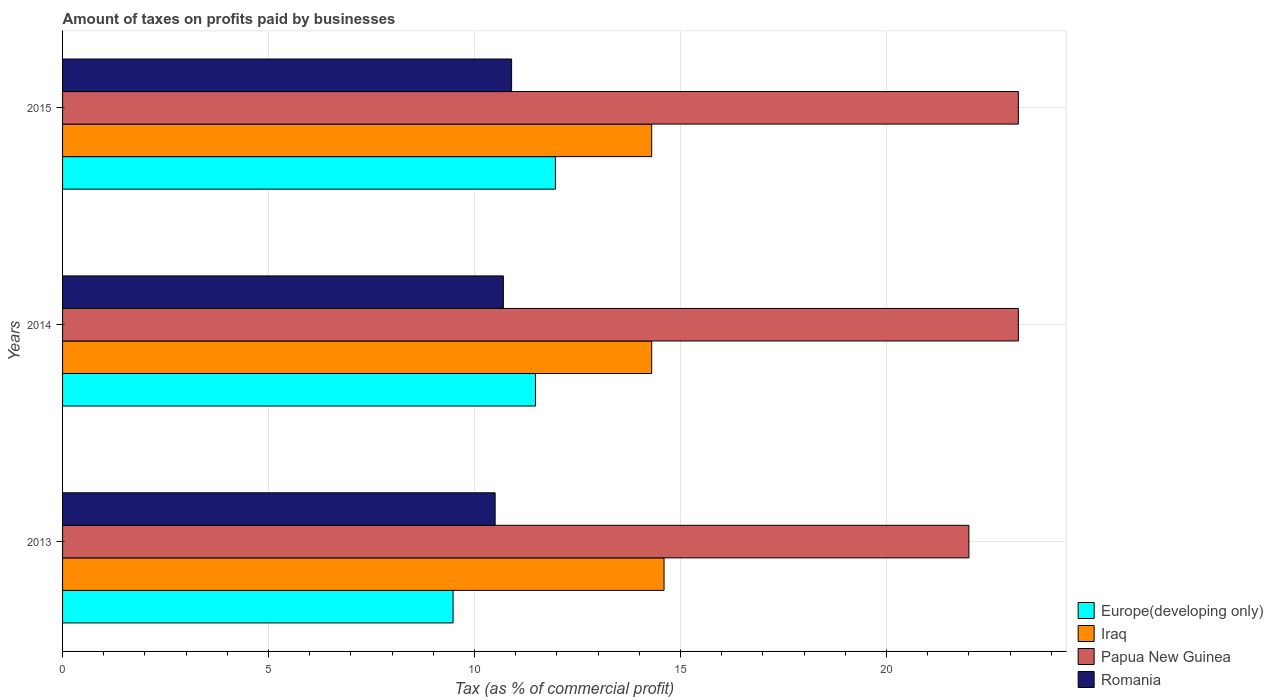How many different coloured bars are there?
Provide a short and direct response. 4. How many bars are there on the 3rd tick from the top?
Keep it short and to the point. 4. How many bars are there on the 2nd tick from the bottom?
Your answer should be compact. 4. What is the label of the 3rd group of bars from the top?
Your answer should be compact. 2013. In how many cases, is the number of bars for a given year not equal to the number of legend labels?
Offer a terse response. 0. Across all years, what is the maximum percentage of taxes paid by businesses in Papua New Guinea?
Offer a terse response. 23.2. In which year was the percentage of taxes paid by businesses in Romania maximum?
Offer a terse response. 2015. In which year was the percentage of taxes paid by businesses in Europe(developing only) minimum?
Give a very brief answer. 2013. What is the total percentage of taxes paid by businesses in Papua New Guinea in the graph?
Make the answer very short. 68.4. What is the difference between the percentage of taxes paid by businesses in Iraq in 2013 and that in 2014?
Offer a very short reply. 0.3. What is the difference between the percentage of taxes paid by businesses in Europe(developing only) in 2013 and the percentage of taxes paid by businesses in Iraq in 2015?
Provide a short and direct response. -4.82. In the year 2014, what is the difference between the percentage of taxes paid by businesses in Romania and percentage of taxes paid by businesses in Europe(developing only)?
Offer a very short reply. -0.78. In how many years, is the percentage of taxes paid by businesses in Papua New Guinea greater than 23 %?
Provide a succinct answer. 2. What is the ratio of the percentage of taxes paid by businesses in Europe(developing only) in 2013 to that in 2014?
Provide a short and direct response. 0.83. What is the difference between the highest and the second highest percentage of taxes paid by businesses in Romania?
Your answer should be very brief. 0.2. What is the difference between the highest and the lowest percentage of taxes paid by businesses in Europe(developing only)?
Provide a short and direct response. 2.48. In how many years, is the percentage of taxes paid by businesses in Romania greater than the average percentage of taxes paid by businesses in Romania taken over all years?
Offer a terse response. 1. Is it the case that in every year, the sum of the percentage of taxes paid by businesses in Papua New Guinea and percentage of taxes paid by businesses in Romania is greater than the sum of percentage of taxes paid by businesses in Iraq and percentage of taxes paid by businesses in Europe(developing only)?
Ensure brevity in your answer.  Yes. What does the 4th bar from the top in 2013 represents?
Give a very brief answer. Europe(developing only). What does the 1st bar from the bottom in 2014 represents?
Offer a terse response. Europe(developing only). Are all the bars in the graph horizontal?
Provide a short and direct response. Yes. How many years are there in the graph?
Keep it short and to the point. 3. Does the graph contain grids?
Make the answer very short. Yes. How many legend labels are there?
Offer a very short reply. 4. What is the title of the graph?
Ensure brevity in your answer.  Amount of taxes on profits paid by businesses. What is the label or title of the X-axis?
Provide a short and direct response. Tax (as % of commercial profit). What is the Tax (as % of commercial profit) of Europe(developing only) in 2013?
Give a very brief answer. 9.48. What is the Tax (as % of commercial profit) of Romania in 2013?
Provide a short and direct response. 10.5. What is the Tax (as % of commercial profit) of Europe(developing only) in 2014?
Make the answer very short. 11.48. What is the Tax (as % of commercial profit) of Iraq in 2014?
Give a very brief answer. 14.3. What is the Tax (as % of commercial profit) in Papua New Guinea in 2014?
Offer a very short reply. 23.2. What is the Tax (as % of commercial profit) of Europe(developing only) in 2015?
Provide a succinct answer. 11.96. What is the Tax (as % of commercial profit) in Papua New Guinea in 2015?
Offer a terse response. 23.2. What is the Tax (as % of commercial profit) of Romania in 2015?
Provide a succinct answer. 10.9. Across all years, what is the maximum Tax (as % of commercial profit) in Europe(developing only)?
Provide a short and direct response. 11.96. Across all years, what is the maximum Tax (as % of commercial profit) of Papua New Guinea?
Provide a short and direct response. 23.2. Across all years, what is the minimum Tax (as % of commercial profit) of Europe(developing only)?
Offer a terse response. 9.48. Across all years, what is the minimum Tax (as % of commercial profit) in Romania?
Your response must be concise. 10.5. What is the total Tax (as % of commercial profit) of Europe(developing only) in the graph?
Offer a very short reply. 32.92. What is the total Tax (as % of commercial profit) of Iraq in the graph?
Keep it short and to the point. 43.2. What is the total Tax (as % of commercial profit) of Papua New Guinea in the graph?
Your answer should be compact. 68.4. What is the total Tax (as % of commercial profit) in Romania in the graph?
Keep it short and to the point. 32.1. What is the difference between the Tax (as % of commercial profit) in Europe(developing only) in 2013 and that in 2014?
Give a very brief answer. -2. What is the difference between the Tax (as % of commercial profit) in Iraq in 2013 and that in 2014?
Ensure brevity in your answer.  0.3. What is the difference between the Tax (as % of commercial profit) in Papua New Guinea in 2013 and that in 2014?
Ensure brevity in your answer.  -1.2. What is the difference between the Tax (as % of commercial profit) in Romania in 2013 and that in 2014?
Provide a short and direct response. -0.2. What is the difference between the Tax (as % of commercial profit) in Europe(developing only) in 2013 and that in 2015?
Ensure brevity in your answer.  -2.48. What is the difference between the Tax (as % of commercial profit) in Iraq in 2013 and that in 2015?
Give a very brief answer. 0.3. What is the difference between the Tax (as % of commercial profit) in Papua New Guinea in 2013 and that in 2015?
Offer a terse response. -1.2. What is the difference between the Tax (as % of commercial profit) in Europe(developing only) in 2014 and that in 2015?
Offer a terse response. -0.48. What is the difference between the Tax (as % of commercial profit) of Papua New Guinea in 2014 and that in 2015?
Your answer should be very brief. 0. What is the difference between the Tax (as % of commercial profit) in Europe(developing only) in 2013 and the Tax (as % of commercial profit) in Iraq in 2014?
Your answer should be very brief. -4.82. What is the difference between the Tax (as % of commercial profit) of Europe(developing only) in 2013 and the Tax (as % of commercial profit) of Papua New Guinea in 2014?
Provide a succinct answer. -13.72. What is the difference between the Tax (as % of commercial profit) in Europe(developing only) in 2013 and the Tax (as % of commercial profit) in Romania in 2014?
Give a very brief answer. -1.22. What is the difference between the Tax (as % of commercial profit) of Papua New Guinea in 2013 and the Tax (as % of commercial profit) of Romania in 2014?
Offer a terse response. 11.3. What is the difference between the Tax (as % of commercial profit) of Europe(developing only) in 2013 and the Tax (as % of commercial profit) of Iraq in 2015?
Keep it short and to the point. -4.82. What is the difference between the Tax (as % of commercial profit) in Europe(developing only) in 2013 and the Tax (as % of commercial profit) in Papua New Guinea in 2015?
Keep it short and to the point. -13.72. What is the difference between the Tax (as % of commercial profit) of Europe(developing only) in 2013 and the Tax (as % of commercial profit) of Romania in 2015?
Your response must be concise. -1.42. What is the difference between the Tax (as % of commercial profit) of Iraq in 2013 and the Tax (as % of commercial profit) of Romania in 2015?
Provide a short and direct response. 3.7. What is the difference between the Tax (as % of commercial profit) in Papua New Guinea in 2013 and the Tax (as % of commercial profit) in Romania in 2015?
Give a very brief answer. 11.1. What is the difference between the Tax (as % of commercial profit) in Europe(developing only) in 2014 and the Tax (as % of commercial profit) in Iraq in 2015?
Make the answer very short. -2.82. What is the difference between the Tax (as % of commercial profit) of Europe(developing only) in 2014 and the Tax (as % of commercial profit) of Papua New Guinea in 2015?
Make the answer very short. -11.72. What is the difference between the Tax (as % of commercial profit) in Europe(developing only) in 2014 and the Tax (as % of commercial profit) in Romania in 2015?
Provide a short and direct response. 0.58. What is the difference between the Tax (as % of commercial profit) of Iraq in 2014 and the Tax (as % of commercial profit) of Papua New Guinea in 2015?
Give a very brief answer. -8.9. What is the difference between the Tax (as % of commercial profit) of Iraq in 2014 and the Tax (as % of commercial profit) of Romania in 2015?
Give a very brief answer. 3.4. What is the difference between the Tax (as % of commercial profit) of Papua New Guinea in 2014 and the Tax (as % of commercial profit) of Romania in 2015?
Your response must be concise. 12.3. What is the average Tax (as % of commercial profit) in Europe(developing only) per year?
Your answer should be very brief. 10.97. What is the average Tax (as % of commercial profit) in Iraq per year?
Provide a short and direct response. 14.4. What is the average Tax (as % of commercial profit) in Papua New Guinea per year?
Offer a terse response. 22.8. In the year 2013, what is the difference between the Tax (as % of commercial profit) of Europe(developing only) and Tax (as % of commercial profit) of Iraq?
Keep it short and to the point. -5.12. In the year 2013, what is the difference between the Tax (as % of commercial profit) in Europe(developing only) and Tax (as % of commercial profit) in Papua New Guinea?
Your answer should be compact. -12.52. In the year 2013, what is the difference between the Tax (as % of commercial profit) in Europe(developing only) and Tax (as % of commercial profit) in Romania?
Offer a very short reply. -1.02. In the year 2013, what is the difference between the Tax (as % of commercial profit) of Papua New Guinea and Tax (as % of commercial profit) of Romania?
Your response must be concise. 11.5. In the year 2014, what is the difference between the Tax (as % of commercial profit) of Europe(developing only) and Tax (as % of commercial profit) of Iraq?
Make the answer very short. -2.82. In the year 2014, what is the difference between the Tax (as % of commercial profit) in Europe(developing only) and Tax (as % of commercial profit) in Papua New Guinea?
Your answer should be compact. -11.72. In the year 2014, what is the difference between the Tax (as % of commercial profit) in Europe(developing only) and Tax (as % of commercial profit) in Romania?
Your answer should be very brief. 0.78. In the year 2014, what is the difference between the Tax (as % of commercial profit) of Iraq and Tax (as % of commercial profit) of Romania?
Keep it short and to the point. 3.6. In the year 2015, what is the difference between the Tax (as % of commercial profit) in Europe(developing only) and Tax (as % of commercial profit) in Iraq?
Give a very brief answer. -2.34. In the year 2015, what is the difference between the Tax (as % of commercial profit) of Europe(developing only) and Tax (as % of commercial profit) of Papua New Guinea?
Offer a terse response. -11.24. In the year 2015, what is the difference between the Tax (as % of commercial profit) in Europe(developing only) and Tax (as % of commercial profit) in Romania?
Give a very brief answer. 1.06. In the year 2015, what is the difference between the Tax (as % of commercial profit) of Iraq and Tax (as % of commercial profit) of Romania?
Provide a succinct answer. 3.4. In the year 2015, what is the difference between the Tax (as % of commercial profit) in Papua New Guinea and Tax (as % of commercial profit) in Romania?
Provide a succinct answer. 12.3. What is the ratio of the Tax (as % of commercial profit) in Europe(developing only) in 2013 to that in 2014?
Your answer should be very brief. 0.83. What is the ratio of the Tax (as % of commercial profit) in Papua New Guinea in 2013 to that in 2014?
Your answer should be compact. 0.95. What is the ratio of the Tax (as % of commercial profit) in Romania in 2013 to that in 2014?
Your answer should be very brief. 0.98. What is the ratio of the Tax (as % of commercial profit) in Europe(developing only) in 2013 to that in 2015?
Ensure brevity in your answer.  0.79. What is the ratio of the Tax (as % of commercial profit) in Papua New Guinea in 2013 to that in 2015?
Make the answer very short. 0.95. What is the ratio of the Tax (as % of commercial profit) in Romania in 2013 to that in 2015?
Your answer should be very brief. 0.96. What is the ratio of the Tax (as % of commercial profit) in Europe(developing only) in 2014 to that in 2015?
Ensure brevity in your answer.  0.96. What is the ratio of the Tax (as % of commercial profit) of Romania in 2014 to that in 2015?
Provide a succinct answer. 0.98. What is the difference between the highest and the second highest Tax (as % of commercial profit) of Europe(developing only)?
Your response must be concise. 0.48. What is the difference between the highest and the second highest Tax (as % of commercial profit) of Papua New Guinea?
Provide a short and direct response. 0. What is the difference between the highest and the second highest Tax (as % of commercial profit) of Romania?
Provide a succinct answer. 0.2. What is the difference between the highest and the lowest Tax (as % of commercial profit) of Europe(developing only)?
Your answer should be very brief. 2.48. What is the difference between the highest and the lowest Tax (as % of commercial profit) of Romania?
Your answer should be very brief. 0.4. 